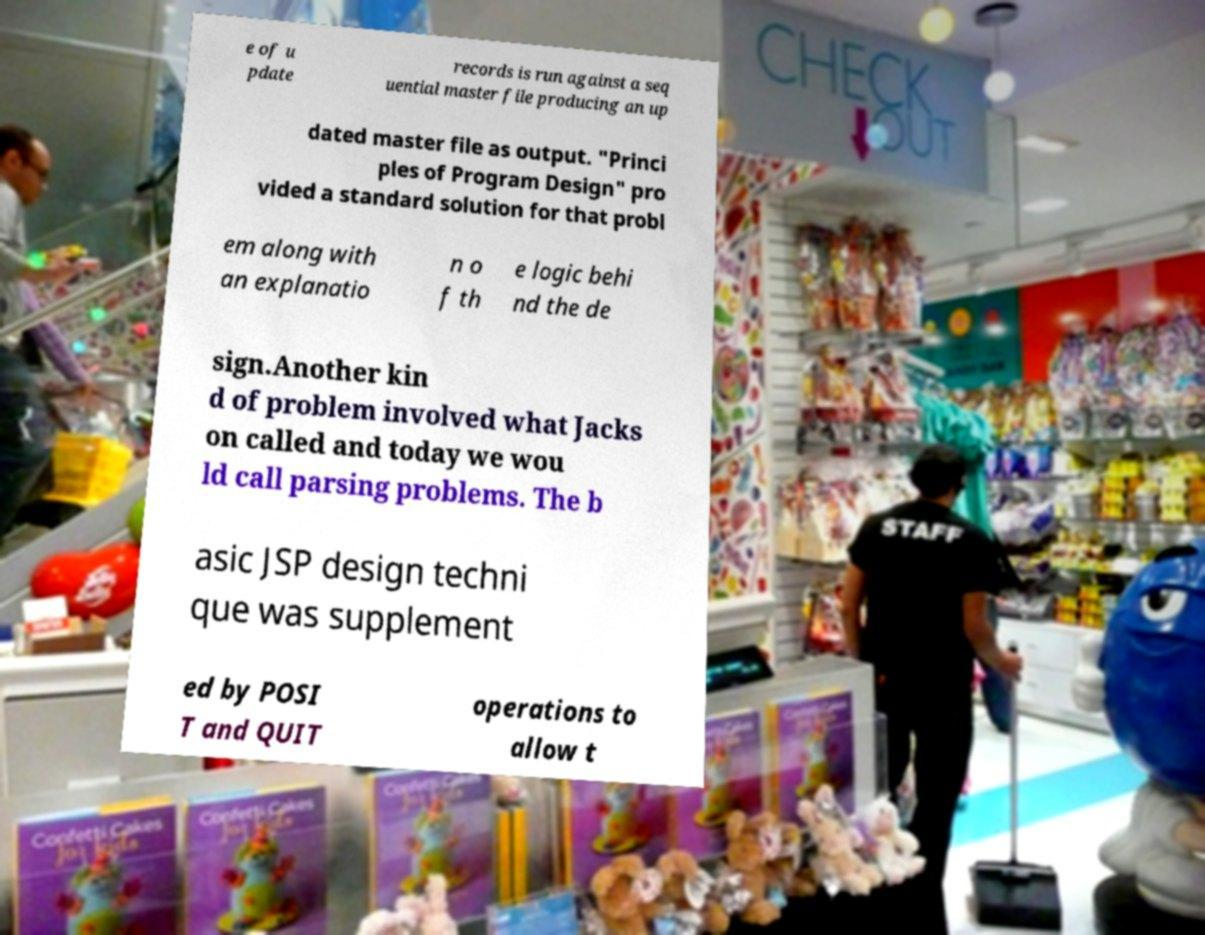Can you read and provide the text displayed in the image?This photo seems to have some interesting text. Can you extract and type it out for me? e of u pdate records is run against a seq uential master file producing an up dated master file as output. "Princi ples of Program Design" pro vided a standard solution for that probl em along with an explanatio n o f th e logic behi nd the de sign.Another kin d of problem involved what Jacks on called and today we wou ld call parsing problems. The b asic JSP design techni que was supplement ed by POSI T and QUIT operations to allow t 